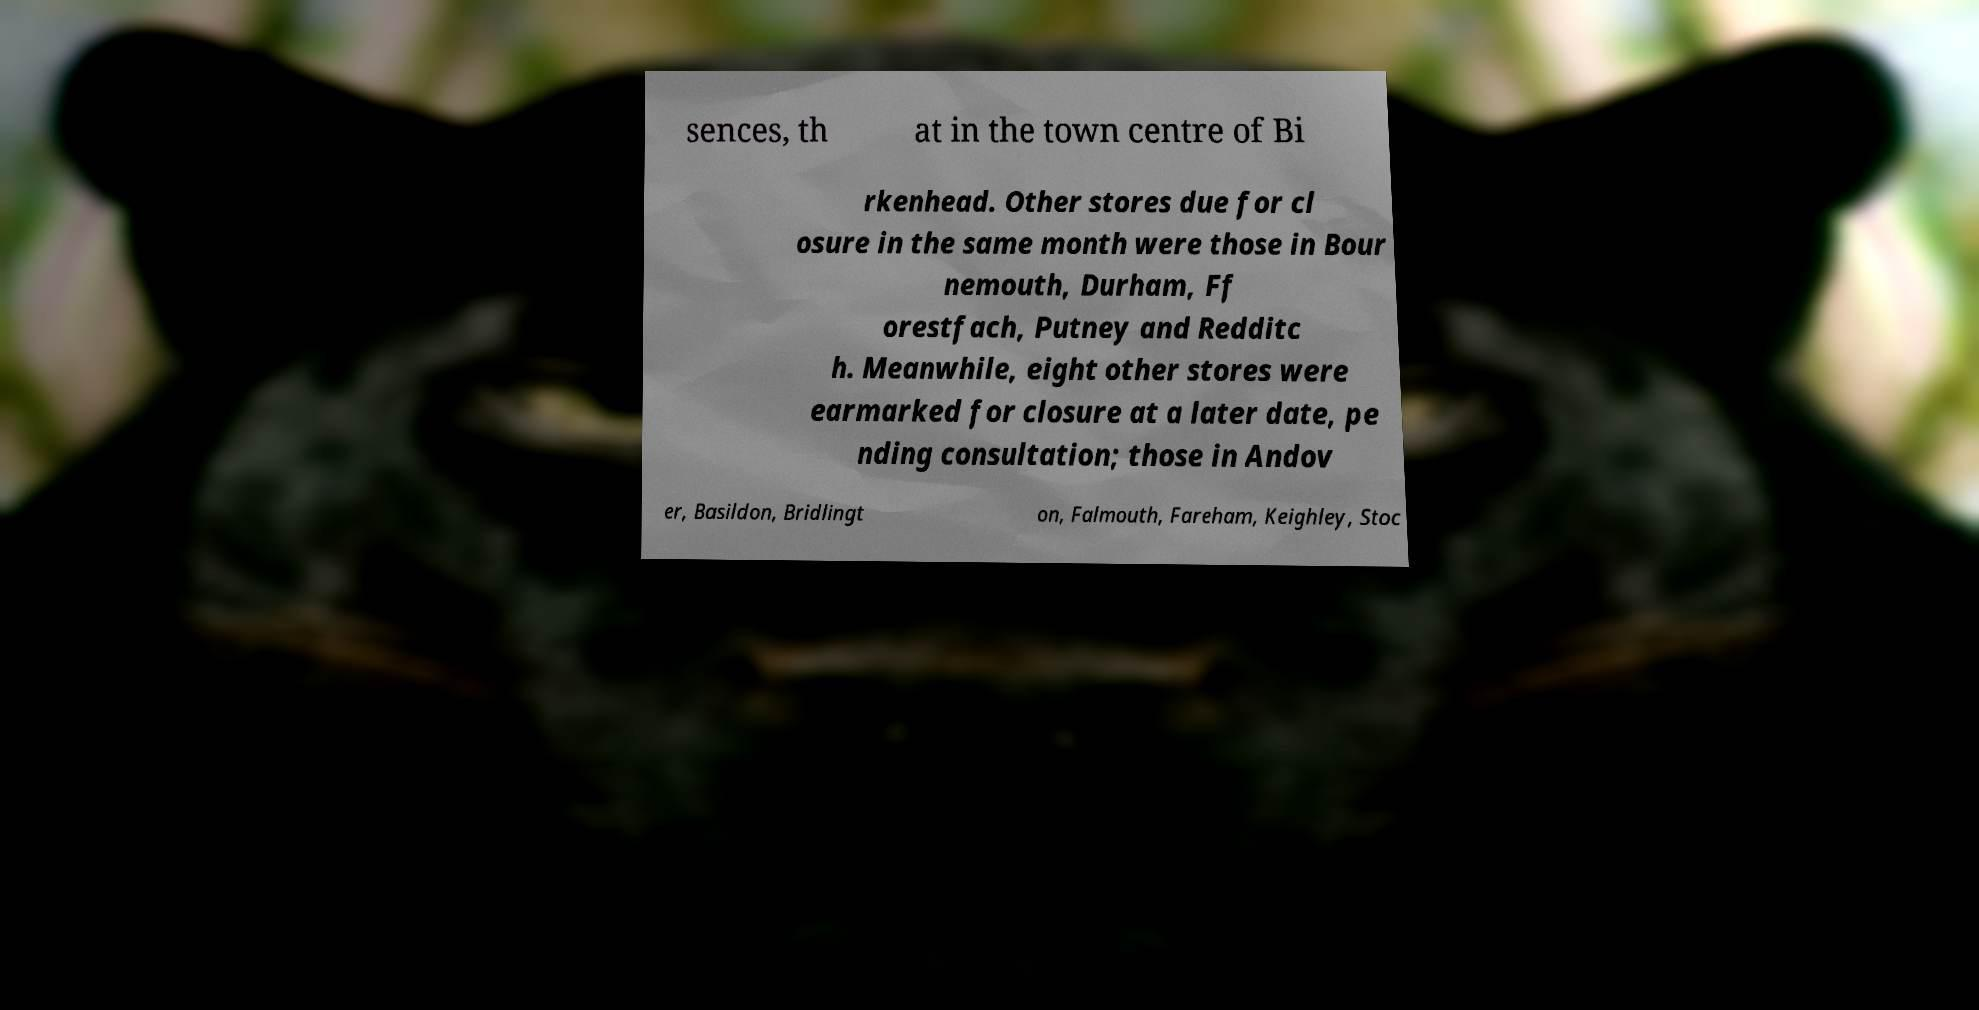Could you extract and type out the text from this image? sences, th at in the town centre of Bi rkenhead. Other stores due for cl osure in the same month were those in Bour nemouth, Durham, Ff orestfach, Putney and Redditc h. Meanwhile, eight other stores were earmarked for closure at a later date, pe nding consultation; those in Andov er, Basildon, Bridlingt on, Falmouth, Fareham, Keighley, Stoc 